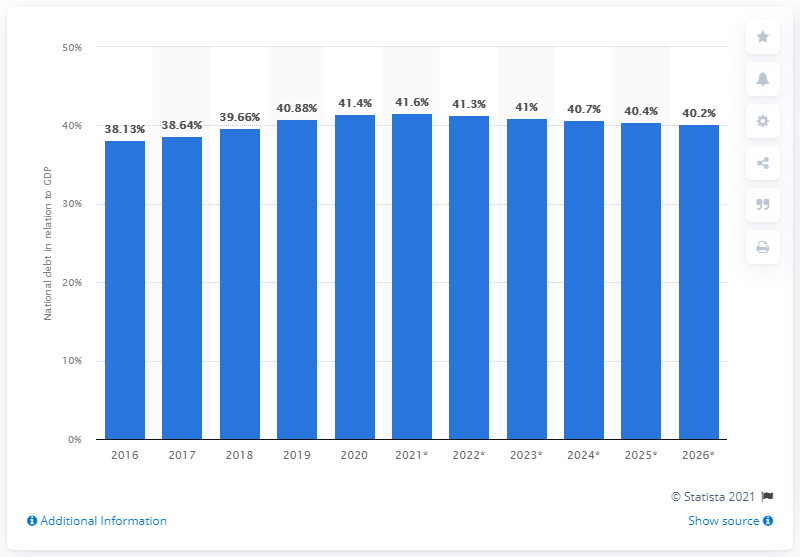Highlight a few significant elements in this photo. In 2020, the national debt of Norway accounted for approximately 41% of the country's GDP. In 2020, the national debt of Norway came to an end. 